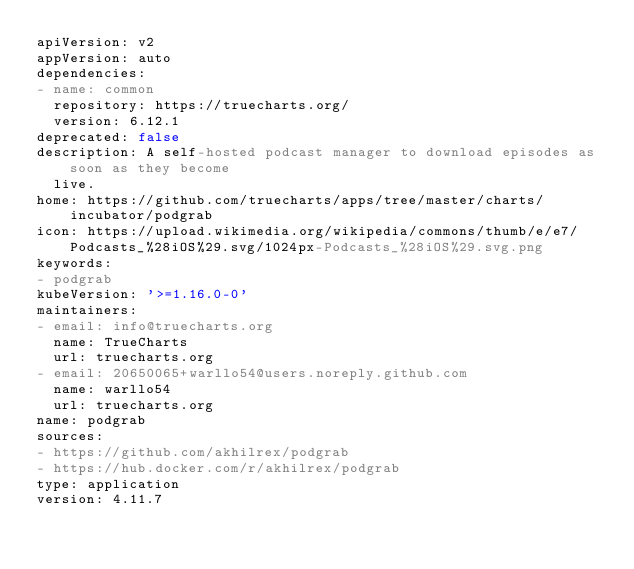<code> <loc_0><loc_0><loc_500><loc_500><_YAML_>apiVersion: v2
appVersion: auto
dependencies:
- name: common
  repository: https://truecharts.org/
  version: 6.12.1
deprecated: false
description: A self-hosted podcast manager to download episodes as soon as they become
  live.
home: https://github.com/truecharts/apps/tree/master/charts/incubator/podgrab
icon: https://upload.wikimedia.org/wikipedia/commons/thumb/e/e7/Podcasts_%28iOS%29.svg/1024px-Podcasts_%28iOS%29.svg.png
keywords:
- podgrab
kubeVersion: '>=1.16.0-0'
maintainers:
- email: info@truecharts.org
  name: TrueCharts
  url: truecharts.org
- email: 20650065+warllo54@users.noreply.github.com
  name: warllo54
  url: truecharts.org
name: podgrab
sources:
- https://github.com/akhilrex/podgrab
- https://hub.docker.com/r/akhilrex/podgrab
type: application
version: 4.11.7
</code> 